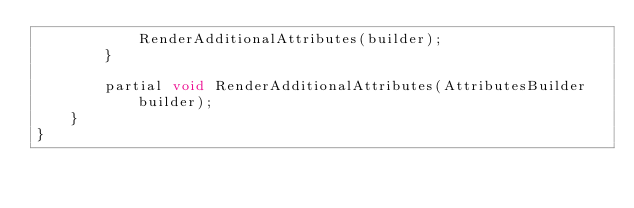<code> <loc_0><loc_0><loc_500><loc_500><_C#_>            RenderAdditionalAttributes(builder);
        }

        partial void RenderAdditionalAttributes(AttributesBuilder builder);
    }
}
</code> 